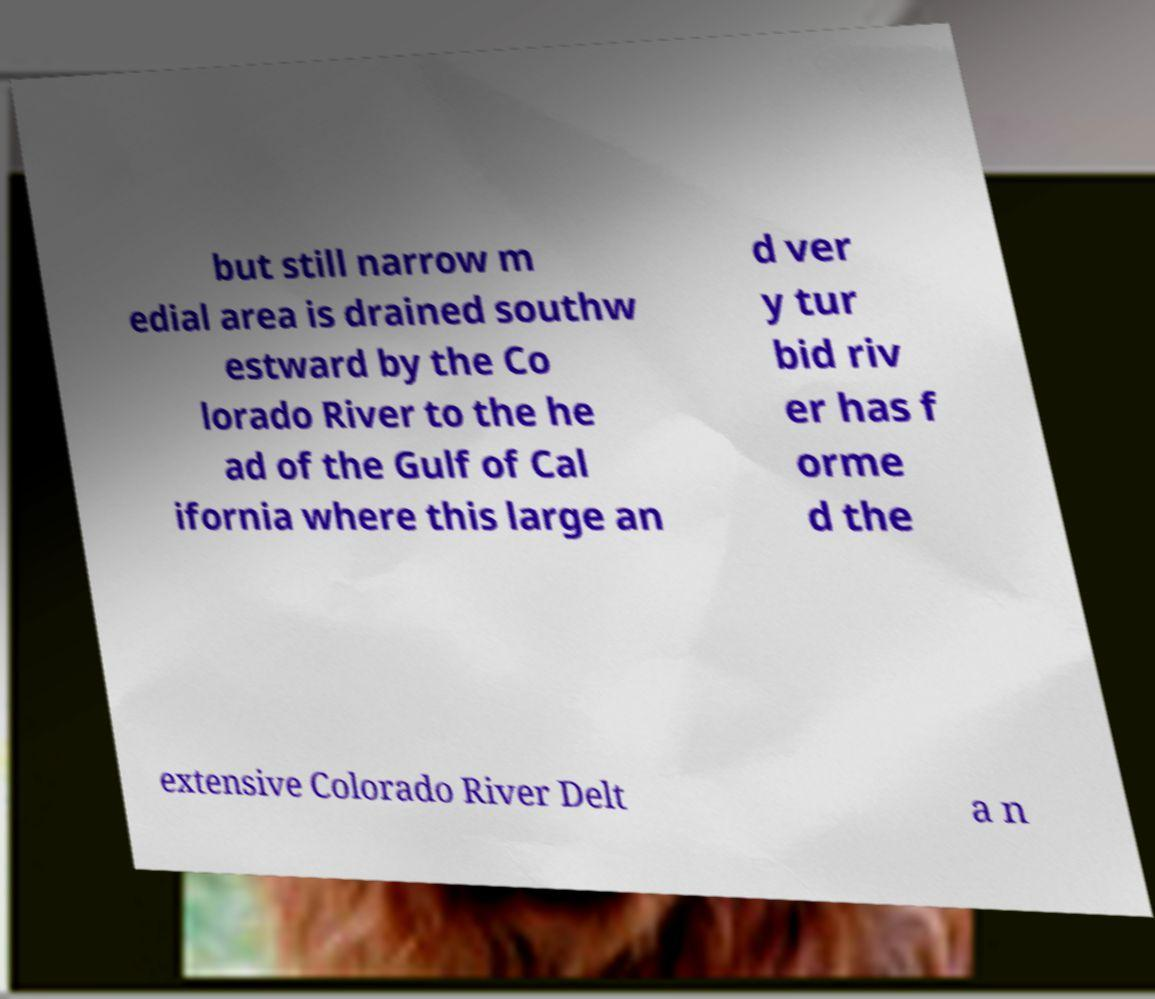Can you read and provide the text displayed in the image?This photo seems to have some interesting text. Can you extract and type it out for me? but still narrow m edial area is drained southw estward by the Co lorado River to the he ad of the Gulf of Cal ifornia where this large an d ver y tur bid riv er has f orme d the extensive Colorado River Delt a n 